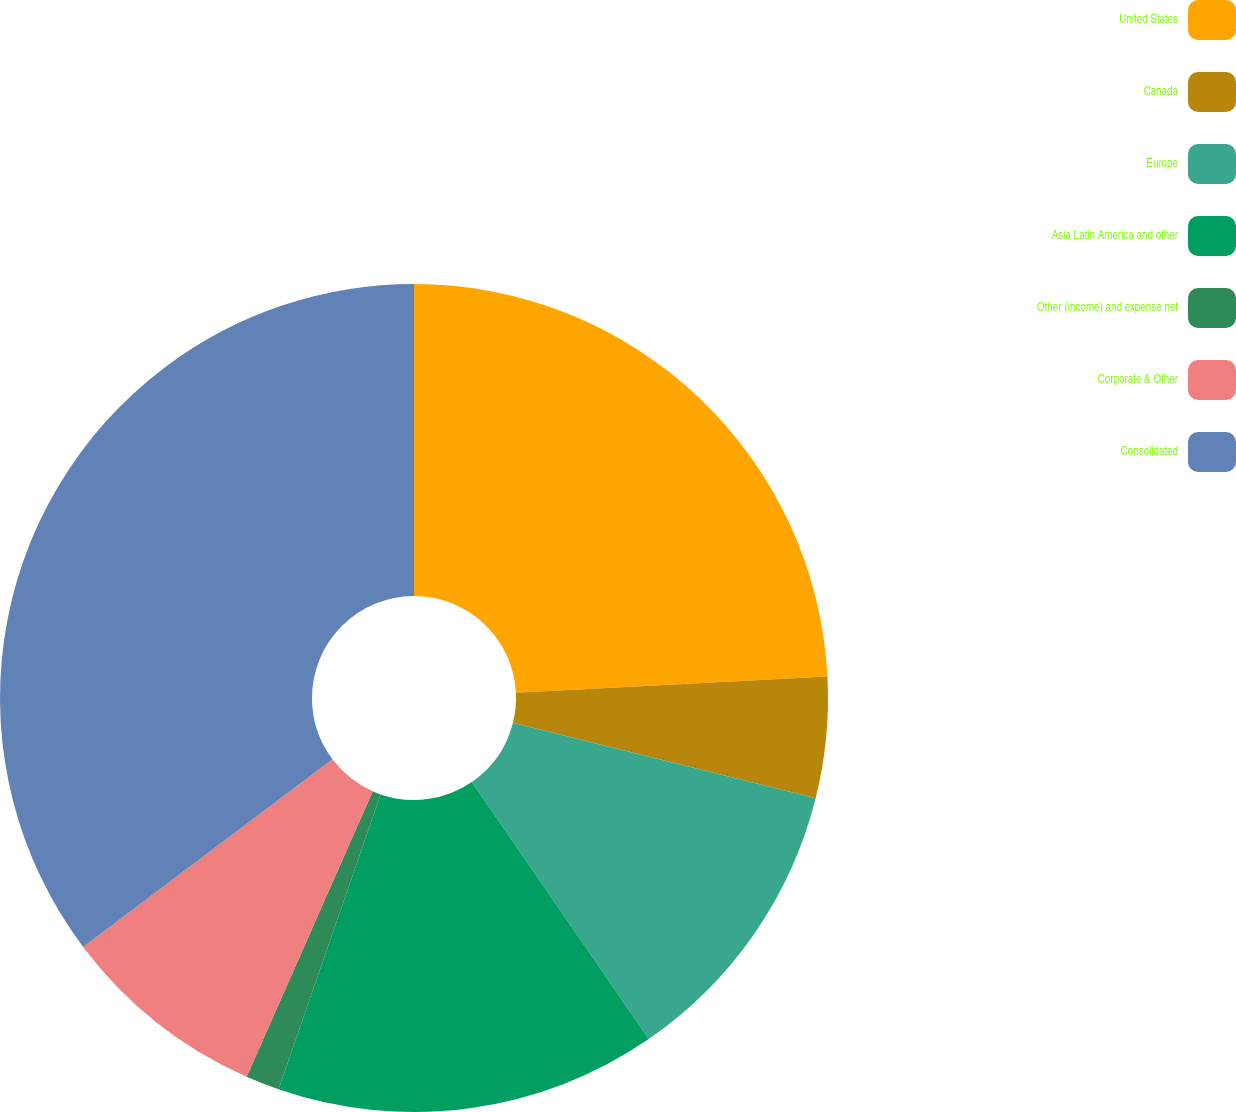Convert chart to OTSL. <chart><loc_0><loc_0><loc_500><loc_500><pie_chart><fcel>United States<fcel>Canada<fcel>Europe<fcel>Asia Latin America and other<fcel>Other (income) and expense net<fcel>Corporate & Other<fcel>Consolidated<nl><fcel>24.18%<fcel>4.72%<fcel>11.51%<fcel>14.9%<fcel>1.32%<fcel>8.11%<fcel>35.27%<nl></chart> 